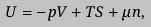<formula> <loc_0><loc_0><loc_500><loc_500>U = - p V + T S + \mu n ,</formula> 